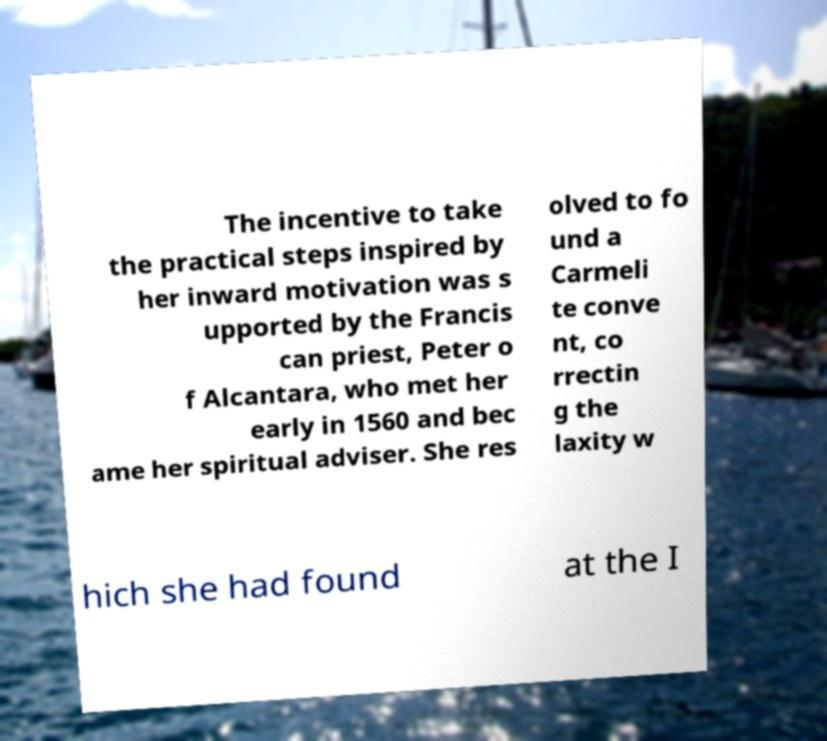Can you read and provide the text displayed in the image?This photo seems to have some interesting text. Can you extract and type it out for me? The incentive to take the practical steps inspired by her inward motivation was s upported by the Francis can priest, Peter o f Alcantara, who met her early in 1560 and bec ame her spiritual adviser. She res olved to fo und a Carmeli te conve nt, co rrectin g the laxity w hich she had found at the I 